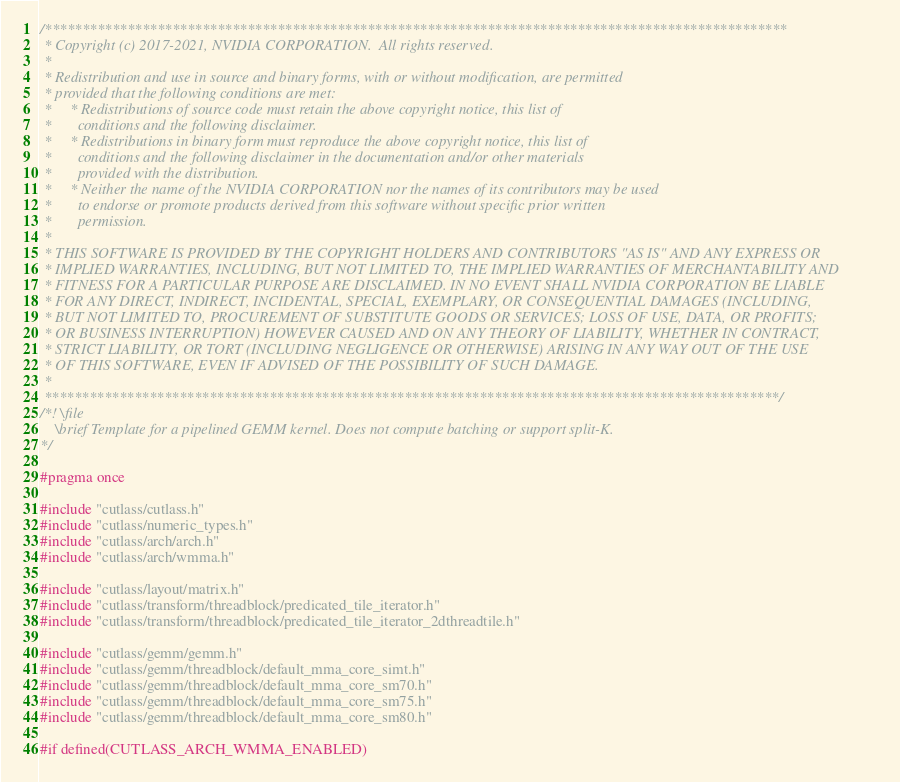Convert code to text. <code><loc_0><loc_0><loc_500><loc_500><_C_>/***************************************************************************************************
 * Copyright (c) 2017-2021, NVIDIA CORPORATION.  All rights reserved.
 *
 * Redistribution and use in source and binary forms, with or without modification, are permitted
 * provided that the following conditions are met:
 *     * Redistributions of source code must retain the above copyright notice, this list of
 *       conditions and the following disclaimer.
 *     * Redistributions in binary form must reproduce the above copyright notice, this list of
 *       conditions and the following disclaimer in the documentation and/or other materials
 *       provided with the distribution.
 *     * Neither the name of the NVIDIA CORPORATION nor the names of its contributors may be used
 *       to endorse or promote products derived from this software without specific prior written
 *       permission.
 *
 * THIS SOFTWARE IS PROVIDED BY THE COPYRIGHT HOLDERS AND CONTRIBUTORS "AS IS" AND ANY EXPRESS OR
 * IMPLIED WARRANTIES, INCLUDING, BUT NOT LIMITED TO, THE IMPLIED WARRANTIES OF MERCHANTABILITY AND
 * FITNESS FOR A PARTICULAR PURPOSE ARE DISCLAIMED. IN NO EVENT SHALL NVIDIA CORPORATION BE LIABLE
 * FOR ANY DIRECT, INDIRECT, INCIDENTAL, SPECIAL, EXEMPLARY, OR CONSEQUENTIAL DAMAGES (INCLUDING,
 * BUT NOT LIMITED TO, PROCUREMENT OF SUBSTITUTE GOODS OR SERVICES; LOSS OF USE, DATA, OR PROFITS;
 * OR BUSINESS INTERRUPTION) HOWEVER CAUSED AND ON ANY THEORY OF LIABILITY, WHETHER IN CONTRACT,
 * STRICT LIABILITY, OR TORT (INCLUDING NEGLIGENCE OR OTHERWISE) ARISING IN ANY WAY OUT OF THE USE
 * OF THIS SOFTWARE, EVEN IF ADVISED OF THE POSSIBILITY OF SUCH DAMAGE.
 *
 **************************************************************************************************/
/*! \file
    \brief Template for a pipelined GEMM kernel. Does not compute batching or support split-K.
*/

#pragma once

#include "cutlass/cutlass.h"
#include "cutlass/numeric_types.h"
#include "cutlass/arch/arch.h"
#include "cutlass/arch/wmma.h"

#include "cutlass/layout/matrix.h"
#include "cutlass/transform/threadblock/predicated_tile_iterator.h"
#include "cutlass/transform/threadblock/predicated_tile_iterator_2dthreadtile.h"

#include "cutlass/gemm/gemm.h"
#include "cutlass/gemm/threadblock/default_mma_core_simt.h"
#include "cutlass/gemm/threadblock/default_mma_core_sm70.h"
#include "cutlass/gemm/threadblock/default_mma_core_sm75.h"
#include "cutlass/gemm/threadblock/default_mma_core_sm80.h"

#if defined(CUTLASS_ARCH_WMMA_ENABLED)</code> 